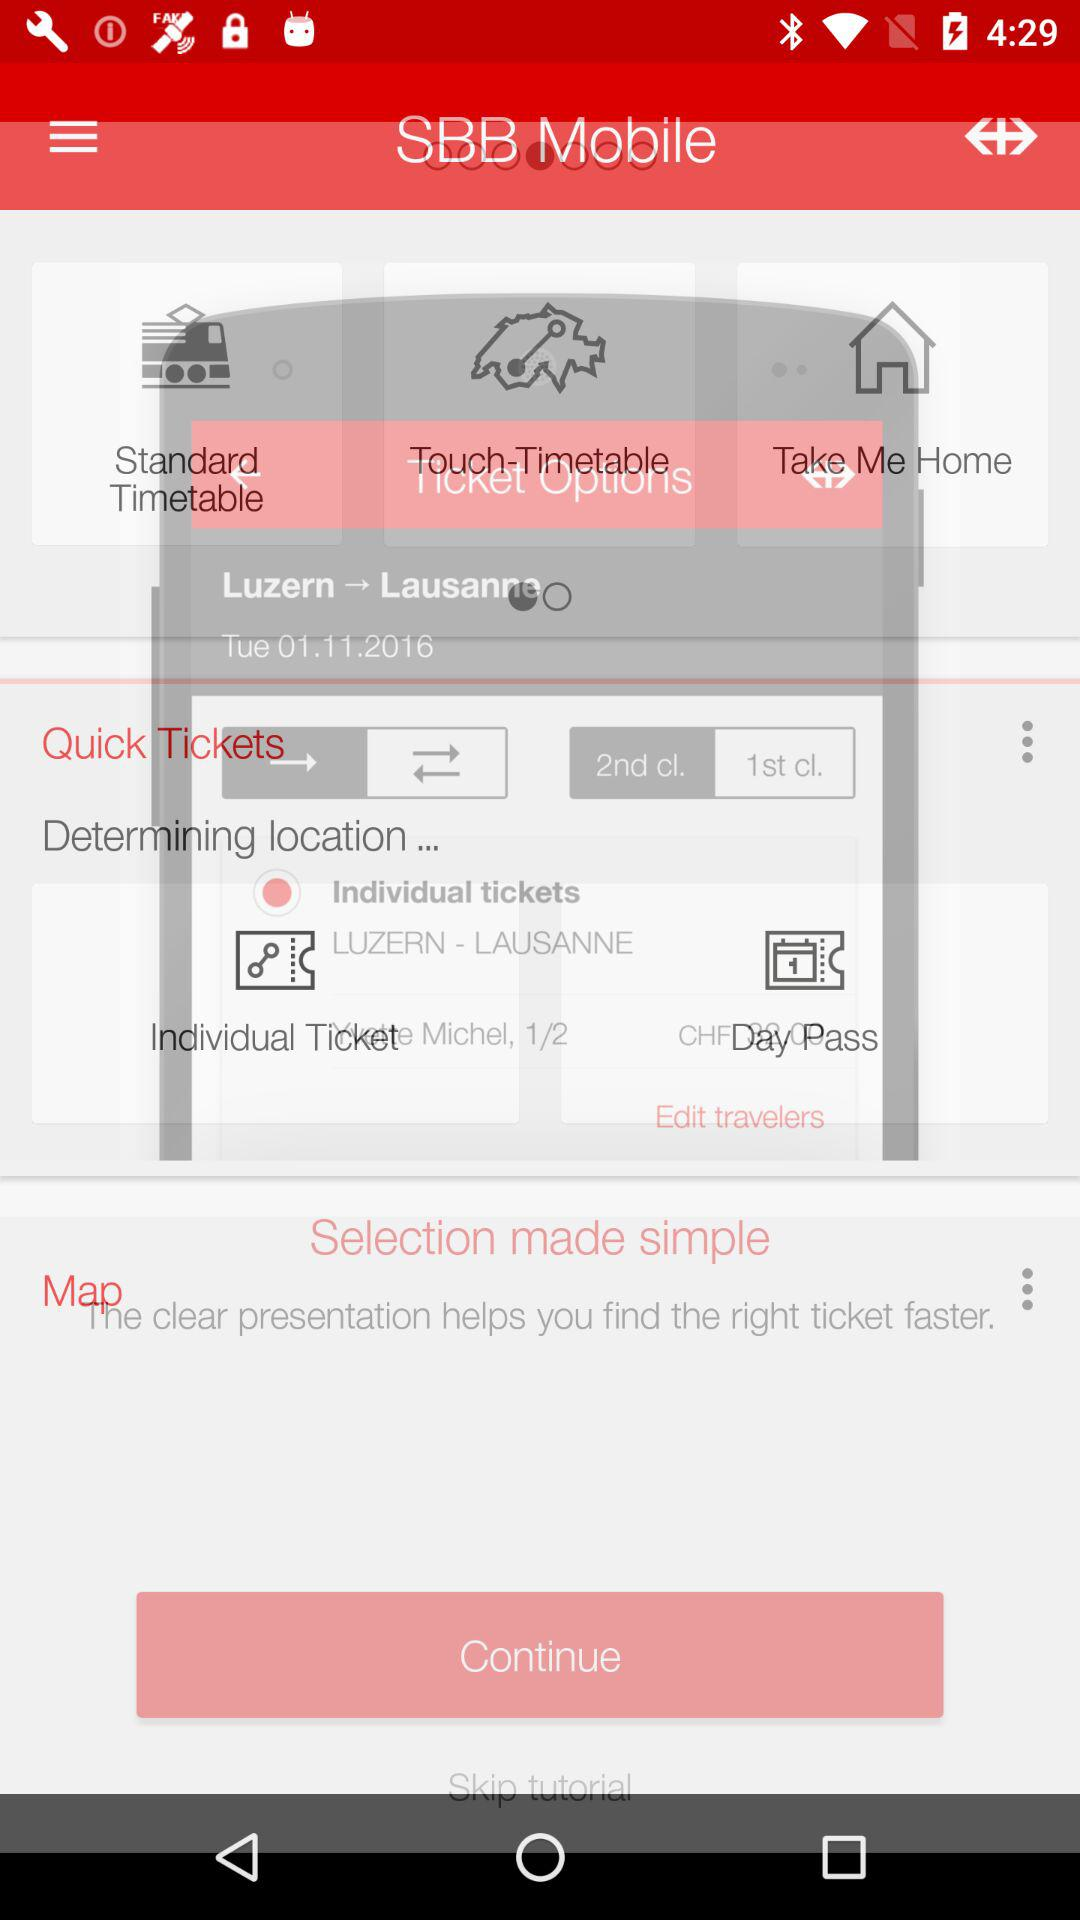How many classes of tickets are available?
Answer the question using a single word or phrase. 2 